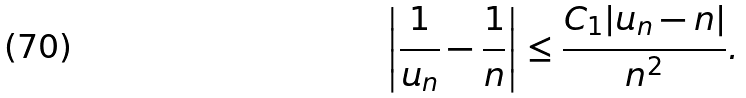Convert formula to latex. <formula><loc_0><loc_0><loc_500><loc_500>\left | \frac { 1 } { u _ { n } } - \frac { 1 } { n } \right | \leq \frac { C _ { 1 } | u _ { n } - n | } { n ^ { 2 } } .</formula> 